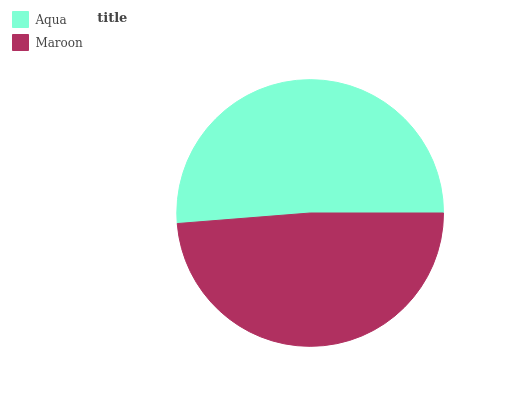Is Maroon the minimum?
Answer yes or no. Yes. Is Aqua the maximum?
Answer yes or no. Yes. Is Maroon the maximum?
Answer yes or no. No. Is Aqua greater than Maroon?
Answer yes or no. Yes. Is Maroon less than Aqua?
Answer yes or no. Yes. Is Maroon greater than Aqua?
Answer yes or no. No. Is Aqua less than Maroon?
Answer yes or no. No. Is Aqua the high median?
Answer yes or no. Yes. Is Maroon the low median?
Answer yes or no. Yes. Is Maroon the high median?
Answer yes or no. No. Is Aqua the low median?
Answer yes or no. No. 